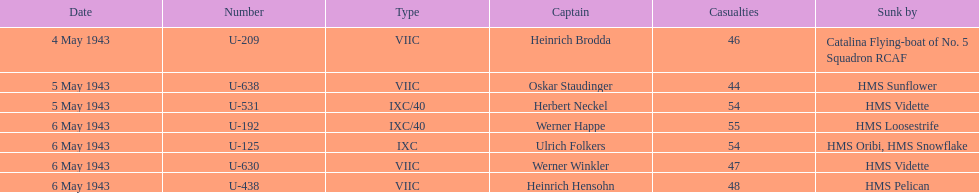Which underwater u-boat had the most significant loss of life? U-192. 